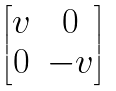<formula> <loc_0><loc_0><loc_500><loc_500>\begin{bmatrix} v & { 0 } \\ { 0 } & { - v } \end{bmatrix}</formula> 